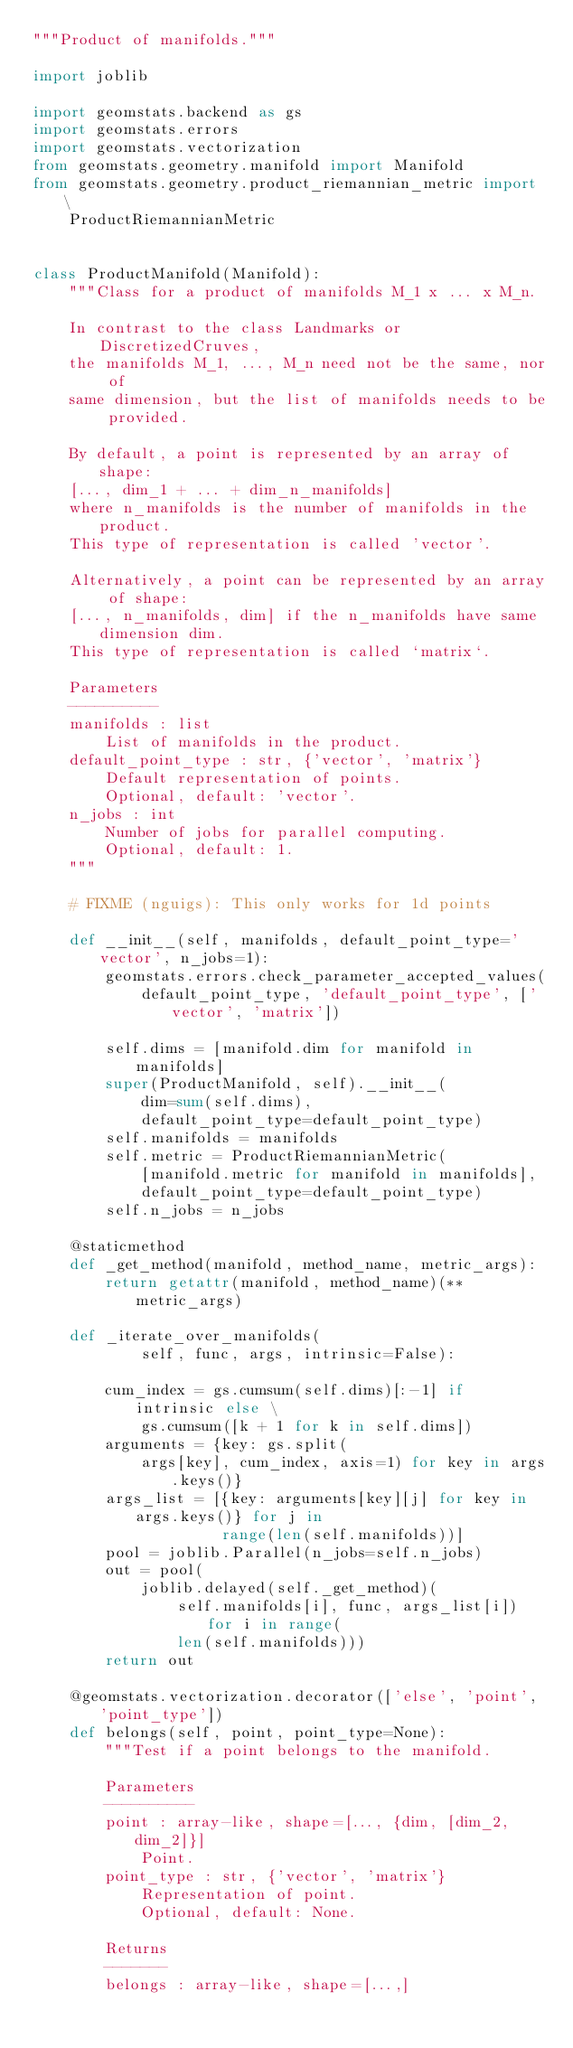Convert code to text. <code><loc_0><loc_0><loc_500><loc_500><_Python_>"""Product of manifolds."""

import joblib

import geomstats.backend as gs
import geomstats.errors
import geomstats.vectorization
from geomstats.geometry.manifold import Manifold
from geomstats.geometry.product_riemannian_metric import \
    ProductRiemannianMetric


class ProductManifold(Manifold):
    """Class for a product of manifolds M_1 x ... x M_n.

    In contrast to the class Landmarks or DiscretizedCruves,
    the manifolds M_1, ..., M_n need not be the same, nor of
    same dimension, but the list of manifolds needs to be provided.

    By default, a point is represented by an array of shape:
    [..., dim_1 + ... + dim_n_manifolds]
    where n_manifolds is the number of manifolds in the product.
    This type of representation is called 'vector'.

    Alternatively, a point can be represented by an array of shape:
    [..., n_manifolds, dim] if the n_manifolds have same dimension dim.
    This type of representation is called `matrix`.

    Parameters
    ----------
    manifolds : list
        List of manifolds in the product.
    default_point_type : str, {'vector', 'matrix'}
        Default representation of points.
        Optional, default: 'vector'.
    n_jobs : int
        Number of jobs for parallel computing.
        Optional, default: 1.
    """

    # FIXME (nguigs): This only works for 1d points

    def __init__(self, manifolds, default_point_type='vector', n_jobs=1):
        geomstats.errors.check_parameter_accepted_values(
            default_point_type, 'default_point_type', ['vector', 'matrix'])

        self.dims = [manifold.dim for manifold in manifolds]
        super(ProductManifold, self).__init__(
            dim=sum(self.dims),
            default_point_type=default_point_type)
        self.manifolds = manifolds
        self.metric = ProductRiemannianMetric(
            [manifold.metric for manifold in manifolds],
            default_point_type=default_point_type)
        self.n_jobs = n_jobs

    @staticmethod
    def _get_method(manifold, method_name, metric_args):
        return getattr(manifold, method_name)(**metric_args)

    def _iterate_over_manifolds(
            self, func, args, intrinsic=False):

        cum_index = gs.cumsum(self.dims)[:-1] if intrinsic else \
            gs.cumsum([k + 1 for k in self.dims])
        arguments = {key: gs.split(
            args[key], cum_index, axis=1) for key in args.keys()}
        args_list = [{key: arguments[key][j] for key in args.keys()} for j in
                     range(len(self.manifolds))]
        pool = joblib.Parallel(n_jobs=self.n_jobs)
        out = pool(
            joblib.delayed(self._get_method)(
                self.manifolds[i], func, args_list[i]) for i in range(
                len(self.manifolds)))
        return out

    @geomstats.vectorization.decorator(['else', 'point', 'point_type'])
    def belongs(self, point, point_type=None):
        """Test if a point belongs to the manifold.

        Parameters
        ----------
        point : array-like, shape=[..., {dim, [dim_2, dim_2]}]
            Point.
        point_type : str, {'vector', 'matrix'}
            Representation of point.
            Optional, default: None.

        Returns
        -------
        belongs : array-like, shape=[...,]</code> 